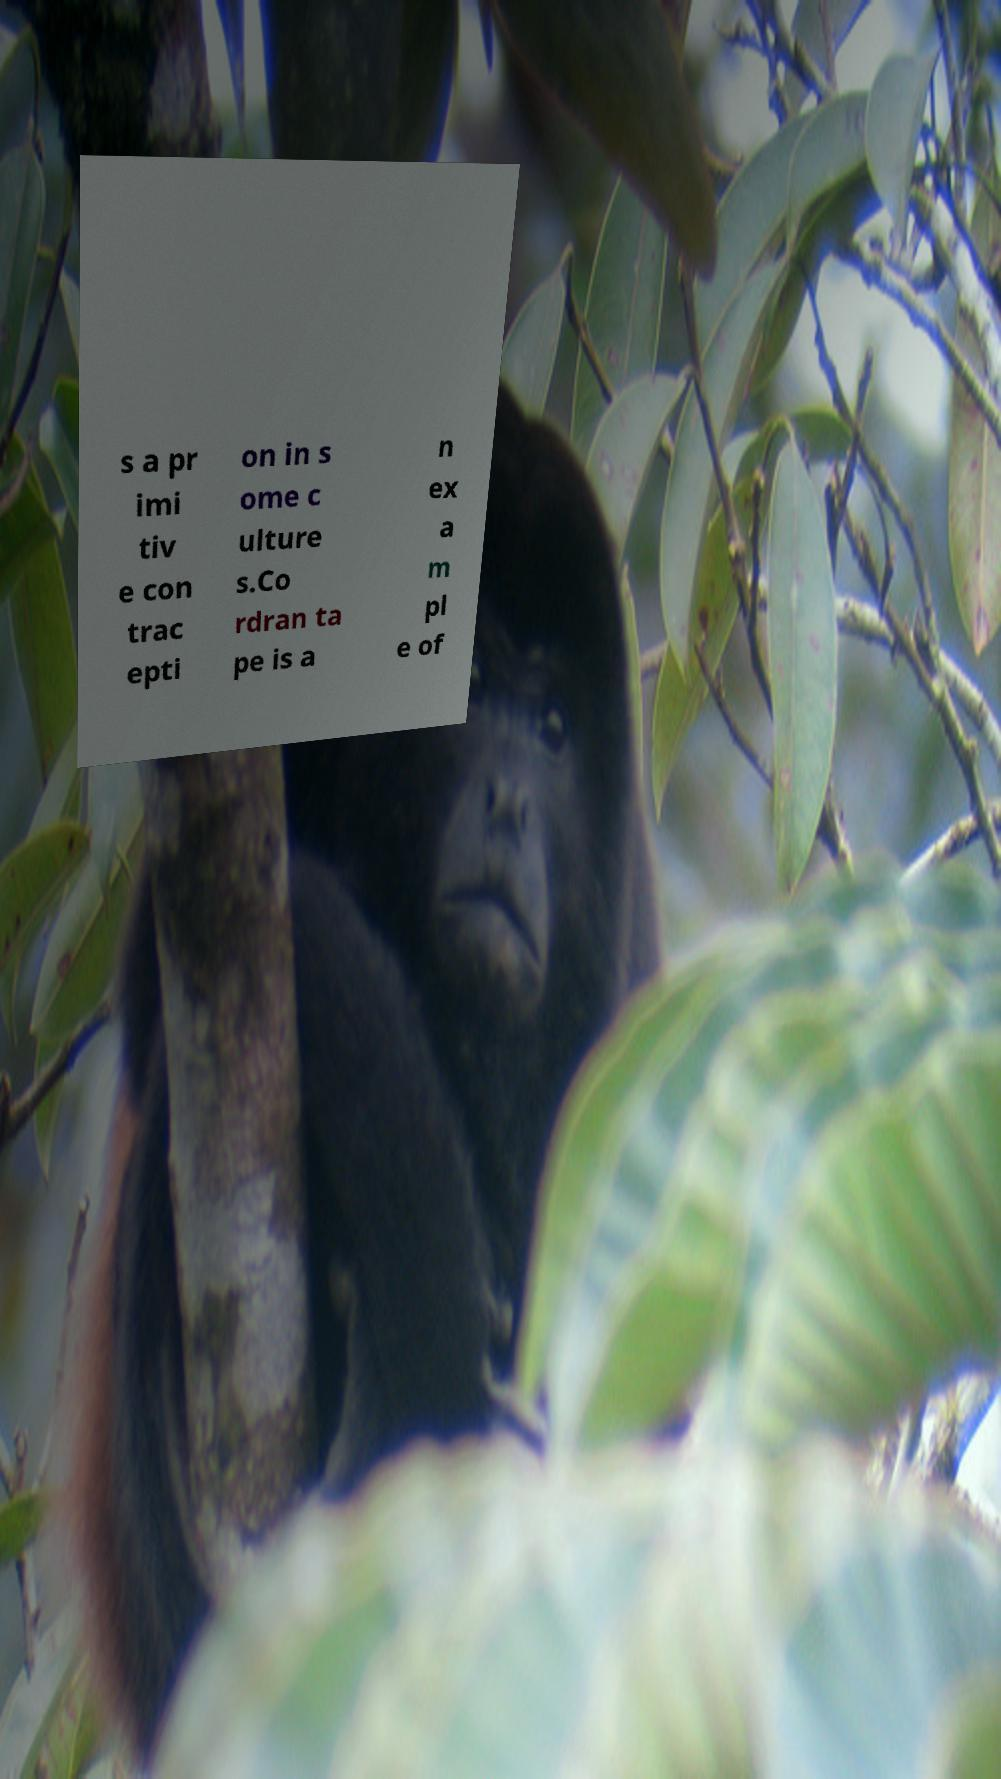Could you assist in decoding the text presented in this image and type it out clearly? s a pr imi tiv e con trac epti on in s ome c ulture s.Co rdran ta pe is a n ex a m pl e of 